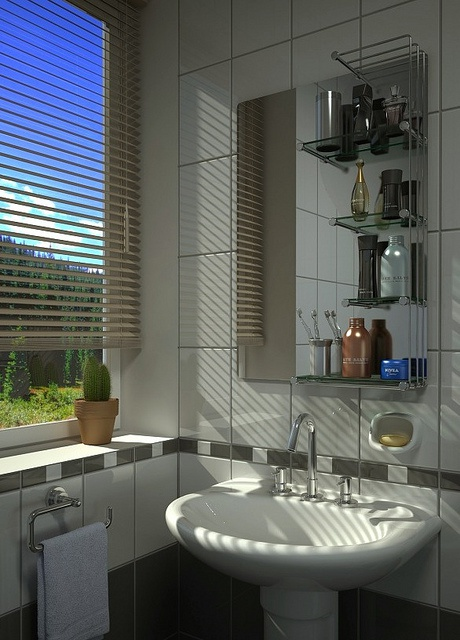Describe the objects in this image and their specific colors. I can see sink in blue, darkgray, black, gray, and beige tones, potted plant in blue, olive, black, darkgreen, and maroon tones, bottle in blue, gray, and darkgray tones, bottle in blue, maroon, black, and gray tones, and bottle in blue, black, and gray tones in this image. 